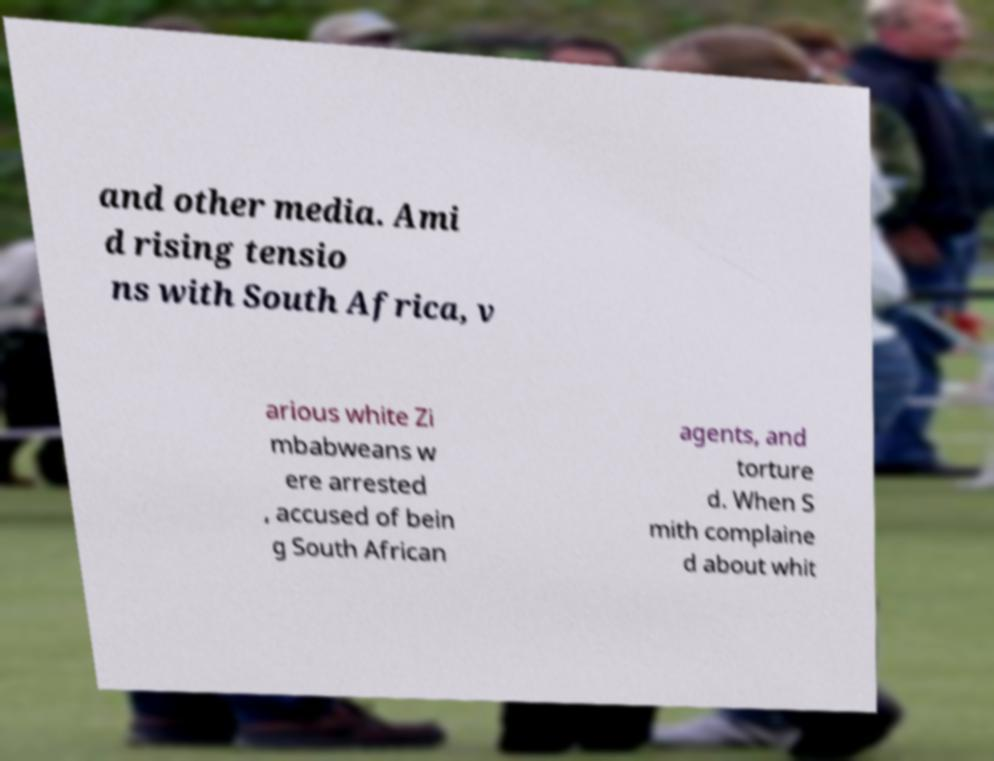What messages or text are displayed in this image? I need them in a readable, typed format. and other media. Ami d rising tensio ns with South Africa, v arious white Zi mbabweans w ere arrested , accused of bein g South African agents, and torture d. When S mith complaine d about whit 